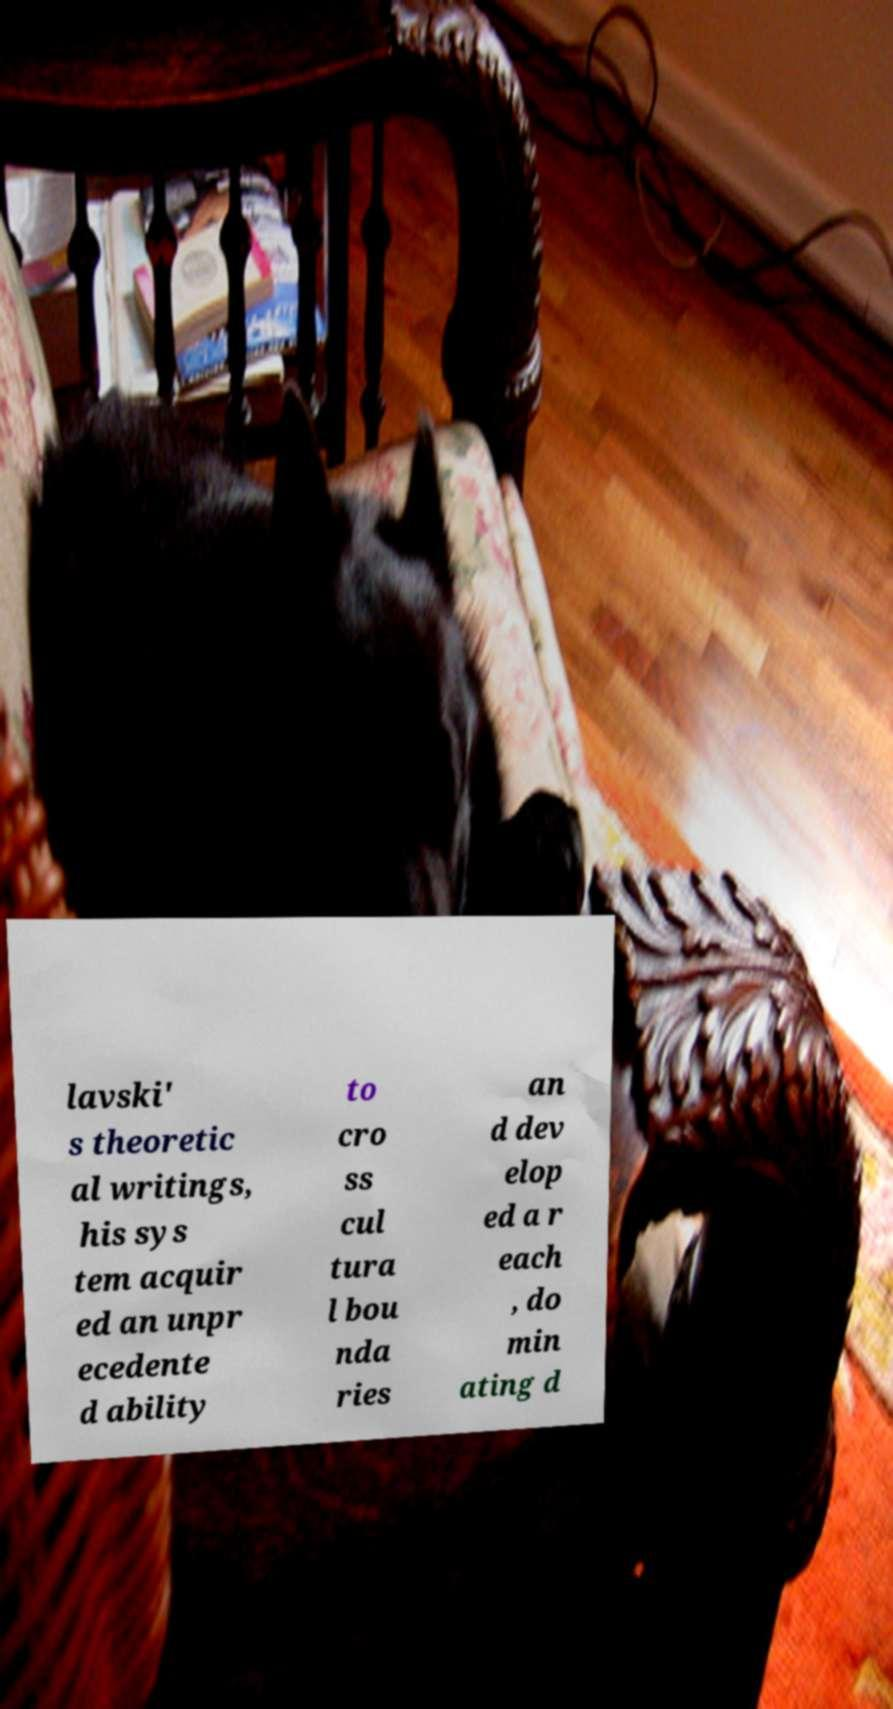Can you accurately transcribe the text from the provided image for me? lavski' s theoretic al writings, his sys tem acquir ed an unpr ecedente d ability to cro ss cul tura l bou nda ries an d dev elop ed a r each , do min ating d 